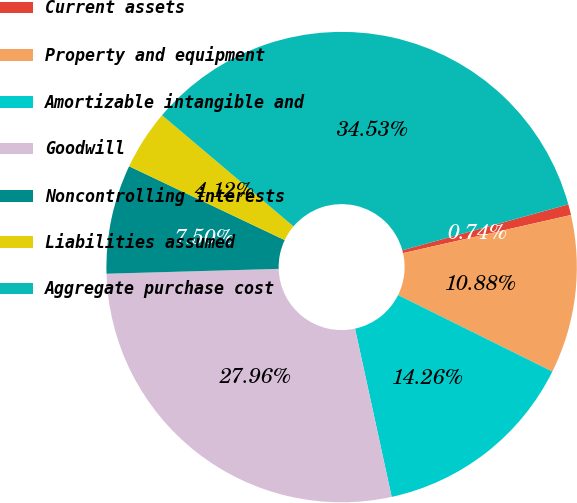Convert chart. <chart><loc_0><loc_0><loc_500><loc_500><pie_chart><fcel>Current assets<fcel>Property and equipment<fcel>Amortizable intangible and<fcel>Goodwill<fcel>Noncontrolling interests<fcel>Liabilities assumed<fcel>Aggregate purchase cost<nl><fcel>0.74%<fcel>10.88%<fcel>14.26%<fcel>27.96%<fcel>7.5%<fcel>4.12%<fcel>34.53%<nl></chart> 